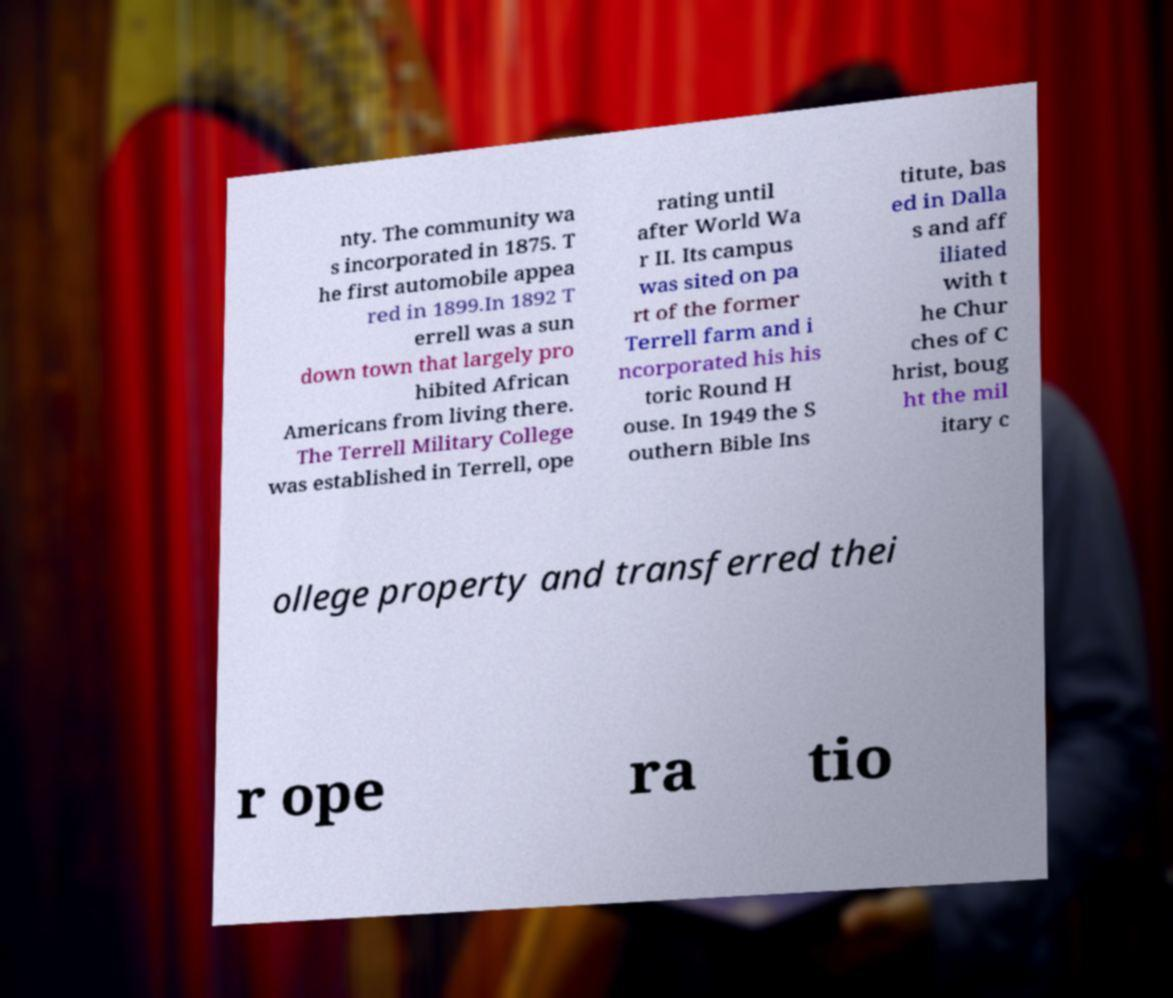Could you extract and type out the text from this image? nty. The community wa s incorporated in 1875. T he first automobile appea red in 1899.In 1892 T errell was a sun down town that largely pro hibited African Americans from living there. The Terrell Military College was established in Terrell, ope rating until after World Wa r II. Its campus was sited on pa rt of the former Terrell farm and i ncorporated his his toric Round H ouse. In 1949 the S outhern Bible Ins titute, bas ed in Dalla s and aff iliated with t he Chur ches of C hrist, boug ht the mil itary c ollege property and transferred thei r ope ra tio 